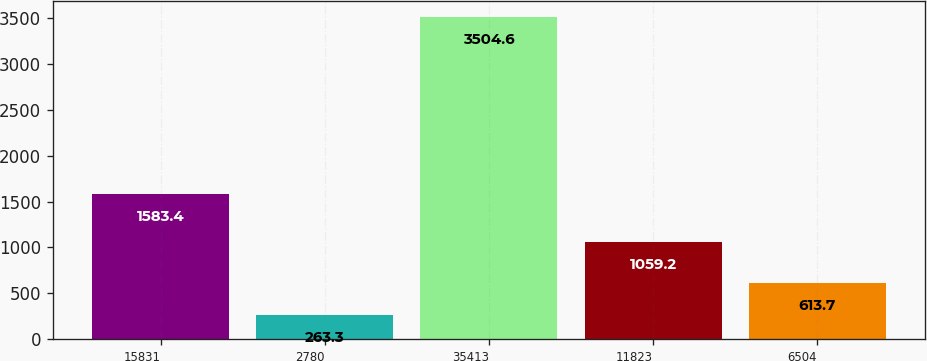Convert chart. <chart><loc_0><loc_0><loc_500><loc_500><bar_chart><fcel>15831<fcel>2780<fcel>35413<fcel>11823<fcel>6504<nl><fcel>1583.4<fcel>263.3<fcel>3504.6<fcel>1059.2<fcel>613.7<nl></chart> 